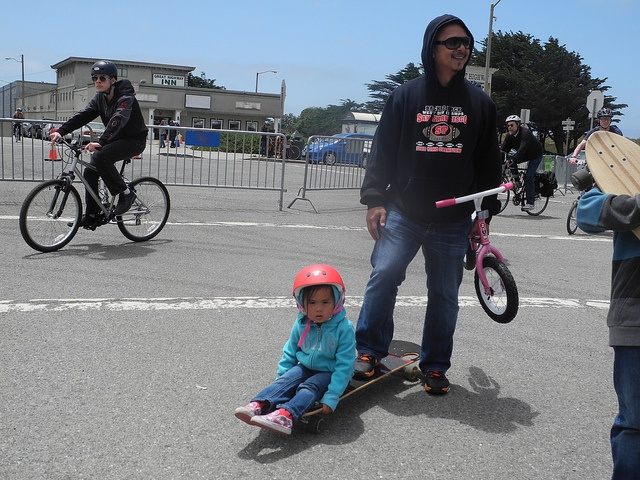Describe the objects in this image and their specific colors. I can see people in lightblue, black, gray, and maroon tones, people in lightblue, blue, teal, and black tones, people in lightblue, black, gray, and blue tones, bicycle in lightblue, darkgray, black, gray, and lightgray tones, and people in lightblue, black, gray, and darkgray tones in this image. 